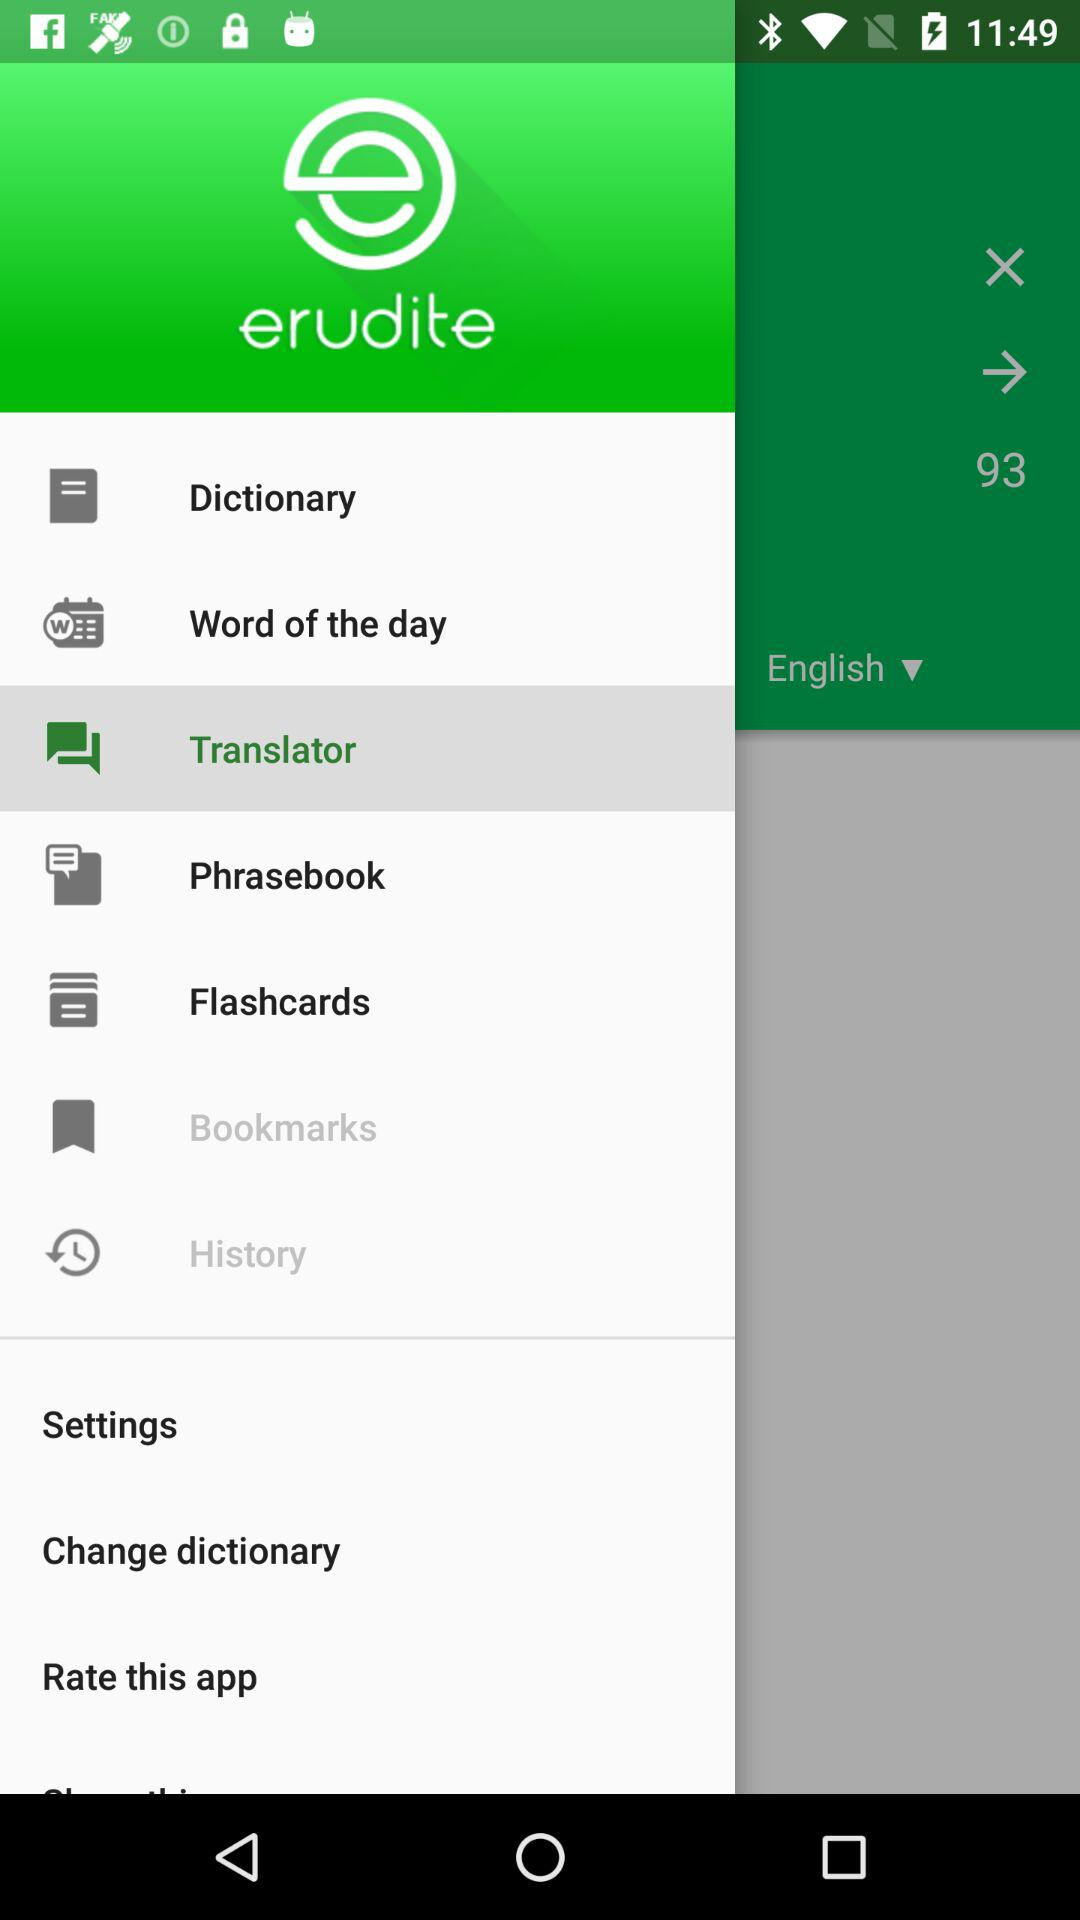What number is shown on the screen? The shown number is 93. 